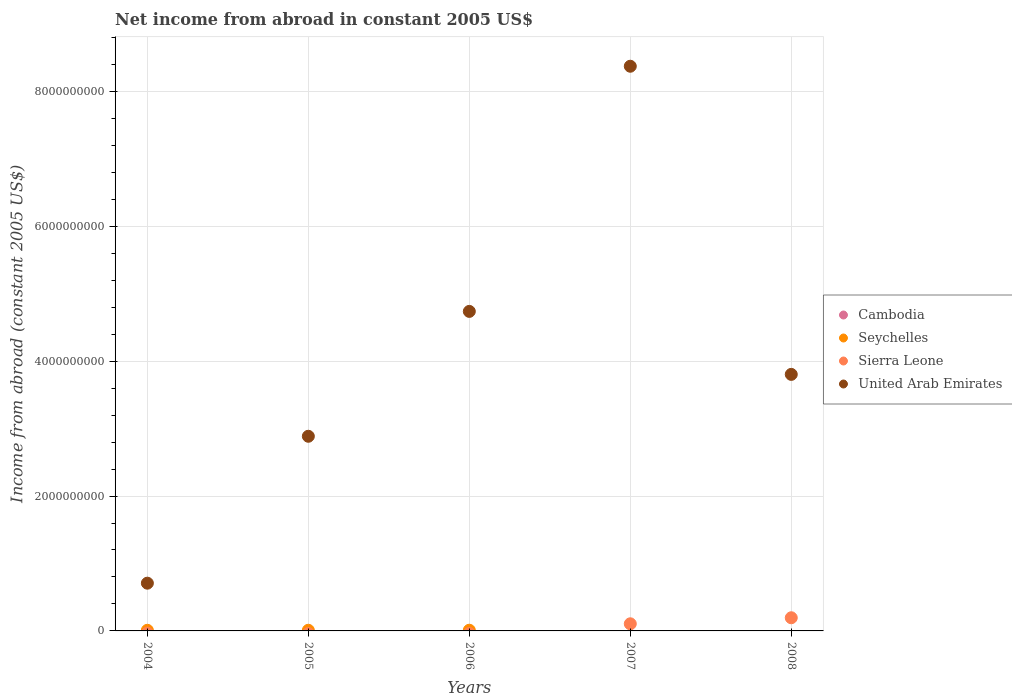What is the net income from abroad in Seychelles in 2005?
Provide a succinct answer. 9.81e+06. Across all years, what is the maximum net income from abroad in Seychelles?
Your answer should be compact. 1.04e+07. What is the difference between the net income from abroad in United Arab Emirates in 2005 and that in 2007?
Give a very brief answer. -5.49e+09. What is the difference between the net income from abroad in Seychelles in 2006 and the net income from abroad in Cambodia in 2005?
Offer a terse response. 1.04e+07. What is the average net income from abroad in United Arab Emirates per year?
Provide a succinct answer. 4.10e+09. What is the ratio of the net income from abroad in United Arab Emirates in 2006 to that in 2007?
Your answer should be very brief. 0.57. Is the net income from abroad in Sierra Leone in 2007 less than that in 2008?
Your answer should be very brief. Yes. What is the difference between the highest and the second highest net income from abroad in United Arab Emirates?
Your answer should be compact. 3.64e+09. What is the difference between the highest and the lowest net income from abroad in Sierra Leone?
Make the answer very short. 1.95e+08. In how many years, is the net income from abroad in Seychelles greater than the average net income from abroad in Seychelles taken over all years?
Offer a very short reply. 3. Is it the case that in every year, the sum of the net income from abroad in Seychelles and net income from abroad in United Arab Emirates  is greater than the sum of net income from abroad in Cambodia and net income from abroad in Sierra Leone?
Ensure brevity in your answer.  Yes. How many dotlines are there?
Keep it short and to the point. 3. How many years are there in the graph?
Your response must be concise. 5. How many legend labels are there?
Your response must be concise. 4. How are the legend labels stacked?
Your answer should be compact. Vertical. What is the title of the graph?
Your answer should be compact. Net income from abroad in constant 2005 US$. Does "European Union" appear as one of the legend labels in the graph?
Ensure brevity in your answer.  No. What is the label or title of the Y-axis?
Make the answer very short. Income from abroad (constant 2005 US$). What is the Income from abroad (constant 2005 US$) of Seychelles in 2004?
Keep it short and to the point. 9.44e+06. What is the Income from abroad (constant 2005 US$) of United Arab Emirates in 2004?
Your answer should be compact. 7.08e+08. What is the Income from abroad (constant 2005 US$) in Seychelles in 2005?
Your response must be concise. 9.81e+06. What is the Income from abroad (constant 2005 US$) of Sierra Leone in 2005?
Your answer should be very brief. 0. What is the Income from abroad (constant 2005 US$) in United Arab Emirates in 2005?
Make the answer very short. 2.89e+09. What is the Income from abroad (constant 2005 US$) of Cambodia in 2006?
Offer a terse response. 0. What is the Income from abroad (constant 2005 US$) of Seychelles in 2006?
Offer a terse response. 1.04e+07. What is the Income from abroad (constant 2005 US$) in United Arab Emirates in 2006?
Offer a terse response. 4.74e+09. What is the Income from abroad (constant 2005 US$) in Seychelles in 2007?
Your answer should be compact. 0. What is the Income from abroad (constant 2005 US$) of Sierra Leone in 2007?
Ensure brevity in your answer.  1.06e+08. What is the Income from abroad (constant 2005 US$) of United Arab Emirates in 2007?
Offer a very short reply. 8.37e+09. What is the Income from abroad (constant 2005 US$) of Seychelles in 2008?
Provide a short and direct response. 0. What is the Income from abroad (constant 2005 US$) of Sierra Leone in 2008?
Make the answer very short. 1.95e+08. What is the Income from abroad (constant 2005 US$) in United Arab Emirates in 2008?
Offer a very short reply. 3.80e+09. Across all years, what is the maximum Income from abroad (constant 2005 US$) of Seychelles?
Ensure brevity in your answer.  1.04e+07. Across all years, what is the maximum Income from abroad (constant 2005 US$) of Sierra Leone?
Provide a short and direct response. 1.95e+08. Across all years, what is the maximum Income from abroad (constant 2005 US$) of United Arab Emirates?
Provide a succinct answer. 8.37e+09. Across all years, what is the minimum Income from abroad (constant 2005 US$) of Seychelles?
Provide a succinct answer. 0. Across all years, what is the minimum Income from abroad (constant 2005 US$) in Sierra Leone?
Ensure brevity in your answer.  0. Across all years, what is the minimum Income from abroad (constant 2005 US$) in United Arab Emirates?
Your answer should be very brief. 7.08e+08. What is the total Income from abroad (constant 2005 US$) in Seychelles in the graph?
Make the answer very short. 2.96e+07. What is the total Income from abroad (constant 2005 US$) of Sierra Leone in the graph?
Offer a terse response. 3.01e+08. What is the total Income from abroad (constant 2005 US$) of United Arab Emirates in the graph?
Make the answer very short. 2.05e+1. What is the difference between the Income from abroad (constant 2005 US$) of Seychelles in 2004 and that in 2005?
Provide a short and direct response. -3.71e+05. What is the difference between the Income from abroad (constant 2005 US$) in United Arab Emirates in 2004 and that in 2005?
Provide a short and direct response. -2.18e+09. What is the difference between the Income from abroad (constant 2005 US$) of Seychelles in 2004 and that in 2006?
Make the answer very short. -9.14e+05. What is the difference between the Income from abroad (constant 2005 US$) in United Arab Emirates in 2004 and that in 2006?
Give a very brief answer. -4.03e+09. What is the difference between the Income from abroad (constant 2005 US$) in United Arab Emirates in 2004 and that in 2007?
Your response must be concise. -7.67e+09. What is the difference between the Income from abroad (constant 2005 US$) in United Arab Emirates in 2004 and that in 2008?
Your response must be concise. -3.10e+09. What is the difference between the Income from abroad (constant 2005 US$) of Seychelles in 2005 and that in 2006?
Provide a succinct answer. -5.42e+05. What is the difference between the Income from abroad (constant 2005 US$) in United Arab Emirates in 2005 and that in 2006?
Offer a very short reply. -1.85e+09. What is the difference between the Income from abroad (constant 2005 US$) in United Arab Emirates in 2005 and that in 2007?
Make the answer very short. -5.49e+09. What is the difference between the Income from abroad (constant 2005 US$) in United Arab Emirates in 2005 and that in 2008?
Offer a very short reply. -9.18e+08. What is the difference between the Income from abroad (constant 2005 US$) in United Arab Emirates in 2006 and that in 2007?
Ensure brevity in your answer.  -3.64e+09. What is the difference between the Income from abroad (constant 2005 US$) in United Arab Emirates in 2006 and that in 2008?
Ensure brevity in your answer.  9.34e+08. What is the difference between the Income from abroad (constant 2005 US$) of Sierra Leone in 2007 and that in 2008?
Keep it short and to the point. -8.93e+07. What is the difference between the Income from abroad (constant 2005 US$) in United Arab Emirates in 2007 and that in 2008?
Your answer should be very brief. 4.57e+09. What is the difference between the Income from abroad (constant 2005 US$) in Seychelles in 2004 and the Income from abroad (constant 2005 US$) in United Arab Emirates in 2005?
Your response must be concise. -2.88e+09. What is the difference between the Income from abroad (constant 2005 US$) of Seychelles in 2004 and the Income from abroad (constant 2005 US$) of United Arab Emirates in 2006?
Your answer should be very brief. -4.73e+09. What is the difference between the Income from abroad (constant 2005 US$) in Seychelles in 2004 and the Income from abroad (constant 2005 US$) in Sierra Leone in 2007?
Provide a succinct answer. -9.64e+07. What is the difference between the Income from abroad (constant 2005 US$) in Seychelles in 2004 and the Income from abroad (constant 2005 US$) in United Arab Emirates in 2007?
Your response must be concise. -8.36e+09. What is the difference between the Income from abroad (constant 2005 US$) of Seychelles in 2004 and the Income from abroad (constant 2005 US$) of Sierra Leone in 2008?
Provide a short and direct response. -1.86e+08. What is the difference between the Income from abroad (constant 2005 US$) in Seychelles in 2004 and the Income from abroad (constant 2005 US$) in United Arab Emirates in 2008?
Keep it short and to the point. -3.79e+09. What is the difference between the Income from abroad (constant 2005 US$) of Seychelles in 2005 and the Income from abroad (constant 2005 US$) of United Arab Emirates in 2006?
Provide a succinct answer. -4.73e+09. What is the difference between the Income from abroad (constant 2005 US$) in Seychelles in 2005 and the Income from abroad (constant 2005 US$) in Sierra Leone in 2007?
Offer a terse response. -9.60e+07. What is the difference between the Income from abroad (constant 2005 US$) in Seychelles in 2005 and the Income from abroad (constant 2005 US$) in United Arab Emirates in 2007?
Your answer should be compact. -8.36e+09. What is the difference between the Income from abroad (constant 2005 US$) in Seychelles in 2005 and the Income from abroad (constant 2005 US$) in Sierra Leone in 2008?
Your answer should be compact. -1.85e+08. What is the difference between the Income from abroad (constant 2005 US$) in Seychelles in 2005 and the Income from abroad (constant 2005 US$) in United Arab Emirates in 2008?
Ensure brevity in your answer.  -3.79e+09. What is the difference between the Income from abroad (constant 2005 US$) in Seychelles in 2006 and the Income from abroad (constant 2005 US$) in Sierra Leone in 2007?
Make the answer very short. -9.55e+07. What is the difference between the Income from abroad (constant 2005 US$) in Seychelles in 2006 and the Income from abroad (constant 2005 US$) in United Arab Emirates in 2007?
Keep it short and to the point. -8.36e+09. What is the difference between the Income from abroad (constant 2005 US$) in Seychelles in 2006 and the Income from abroad (constant 2005 US$) in Sierra Leone in 2008?
Provide a short and direct response. -1.85e+08. What is the difference between the Income from abroad (constant 2005 US$) of Seychelles in 2006 and the Income from abroad (constant 2005 US$) of United Arab Emirates in 2008?
Make the answer very short. -3.79e+09. What is the difference between the Income from abroad (constant 2005 US$) of Sierra Leone in 2007 and the Income from abroad (constant 2005 US$) of United Arab Emirates in 2008?
Offer a terse response. -3.70e+09. What is the average Income from abroad (constant 2005 US$) of Cambodia per year?
Your answer should be very brief. 0. What is the average Income from abroad (constant 2005 US$) of Seychelles per year?
Your answer should be compact. 5.92e+06. What is the average Income from abroad (constant 2005 US$) of Sierra Leone per year?
Your response must be concise. 6.02e+07. What is the average Income from abroad (constant 2005 US$) of United Arab Emirates per year?
Keep it short and to the point. 4.10e+09. In the year 2004, what is the difference between the Income from abroad (constant 2005 US$) of Seychelles and Income from abroad (constant 2005 US$) of United Arab Emirates?
Ensure brevity in your answer.  -6.99e+08. In the year 2005, what is the difference between the Income from abroad (constant 2005 US$) of Seychelles and Income from abroad (constant 2005 US$) of United Arab Emirates?
Offer a terse response. -2.88e+09. In the year 2006, what is the difference between the Income from abroad (constant 2005 US$) of Seychelles and Income from abroad (constant 2005 US$) of United Arab Emirates?
Ensure brevity in your answer.  -4.73e+09. In the year 2007, what is the difference between the Income from abroad (constant 2005 US$) of Sierra Leone and Income from abroad (constant 2005 US$) of United Arab Emirates?
Offer a very short reply. -8.27e+09. In the year 2008, what is the difference between the Income from abroad (constant 2005 US$) of Sierra Leone and Income from abroad (constant 2005 US$) of United Arab Emirates?
Offer a very short reply. -3.61e+09. What is the ratio of the Income from abroad (constant 2005 US$) in Seychelles in 2004 to that in 2005?
Offer a very short reply. 0.96. What is the ratio of the Income from abroad (constant 2005 US$) of United Arab Emirates in 2004 to that in 2005?
Provide a succinct answer. 0.25. What is the ratio of the Income from abroad (constant 2005 US$) in Seychelles in 2004 to that in 2006?
Your answer should be compact. 0.91. What is the ratio of the Income from abroad (constant 2005 US$) in United Arab Emirates in 2004 to that in 2006?
Keep it short and to the point. 0.15. What is the ratio of the Income from abroad (constant 2005 US$) of United Arab Emirates in 2004 to that in 2007?
Offer a terse response. 0.08. What is the ratio of the Income from abroad (constant 2005 US$) of United Arab Emirates in 2004 to that in 2008?
Make the answer very short. 0.19. What is the ratio of the Income from abroad (constant 2005 US$) in Seychelles in 2005 to that in 2006?
Keep it short and to the point. 0.95. What is the ratio of the Income from abroad (constant 2005 US$) of United Arab Emirates in 2005 to that in 2006?
Provide a short and direct response. 0.61. What is the ratio of the Income from abroad (constant 2005 US$) of United Arab Emirates in 2005 to that in 2007?
Offer a terse response. 0.34. What is the ratio of the Income from abroad (constant 2005 US$) in United Arab Emirates in 2005 to that in 2008?
Your answer should be compact. 0.76. What is the ratio of the Income from abroad (constant 2005 US$) of United Arab Emirates in 2006 to that in 2007?
Make the answer very short. 0.57. What is the ratio of the Income from abroad (constant 2005 US$) of United Arab Emirates in 2006 to that in 2008?
Make the answer very short. 1.25. What is the ratio of the Income from abroad (constant 2005 US$) in Sierra Leone in 2007 to that in 2008?
Your answer should be very brief. 0.54. What is the ratio of the Income from abroad (constant 2005 US$) of United Arab Emirates in 2007 to that in 2008?
Give a very brief answer. 2.2. What is the difference between the highest and the second highest Income from abroad (constant 2005 US$) in Seychelles?
Make the answer very short. 5.42e+05. What is the difference between the highest and the second highest Income from abroad (constant 2005 US$) in United Arab Emirates?
Offer a terse response. 3.64e+09. What is the difference between the highest and the lowest Income from abroad (constant 2005 US$) of Seychelles?
Provide a short and direct response. 1.04e+07. What is the difference between the highest and the lowest Income from abroad (constant 2005 US$) in Sierra Leone?
Your answer should be compact. 1.95e+08. What is the difference between the highest and the lowest Income from abroad (constant 2005 US$) of United Arab Emirates?
Keep it short and to the point. 7.67e+09. 